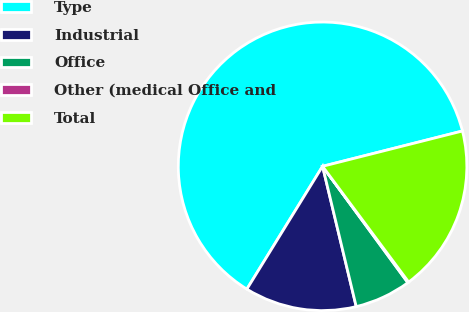Convert chart to OTSL. <chart><loc_0><loc_0><loc_500><loc_500><pie_chart><fcel>Type<fcel>Industrial<fcel>Office<fcel>Other (medical Office and<fcel>Total<nl><fcel>62.28%<fcel>12.54%<fcel>6.32%<fcel>0.11%<fcel>18.76%<nl></chart> 